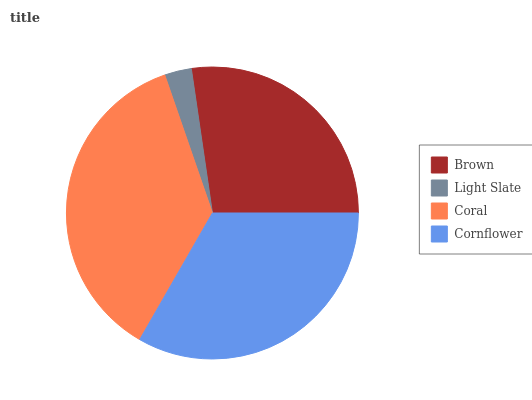Is Light Slate the minimum?
Answer yes or no. Yes. Is Coral the maximum?
Answer yes or no. Yes. Is Coral the minimum?
Answer yes or no. No. Is Light Slate the maximum?
Answer yes or no. No. Is Coral greater than Light Slate?
Answer yes or no. Yes. Is Light Slate less than Coral?
Answer yes or no. Yes. Is Light Slate greater than Coral?
Answer yes or no. No. Is Coral less than Light Slate?
Answer yes or no. No. Is Cornflower the high median?
Answer yes or no. Yes. Is Brown the low median?
Answer yes or no. Yes. Is Light Slate the high median?
Answer yes or no. No. Is Light Slate the low median?
Answer yes or no. No. 